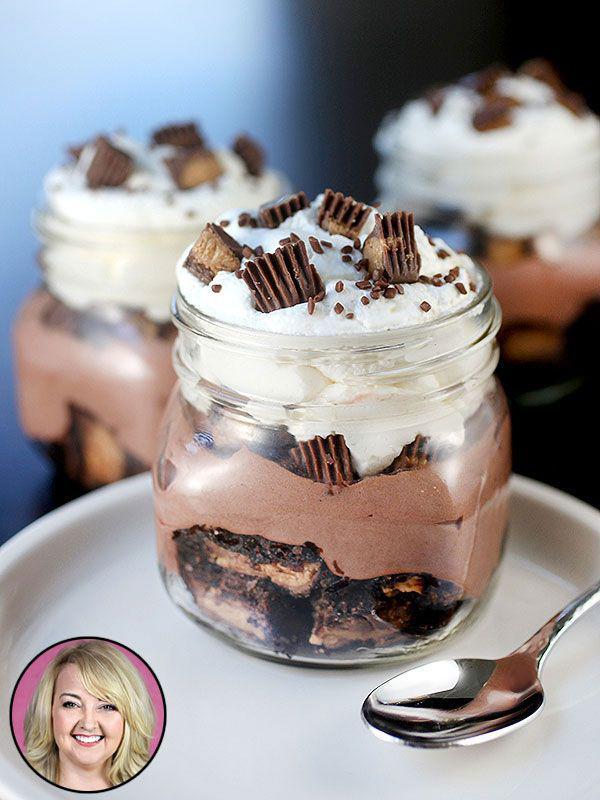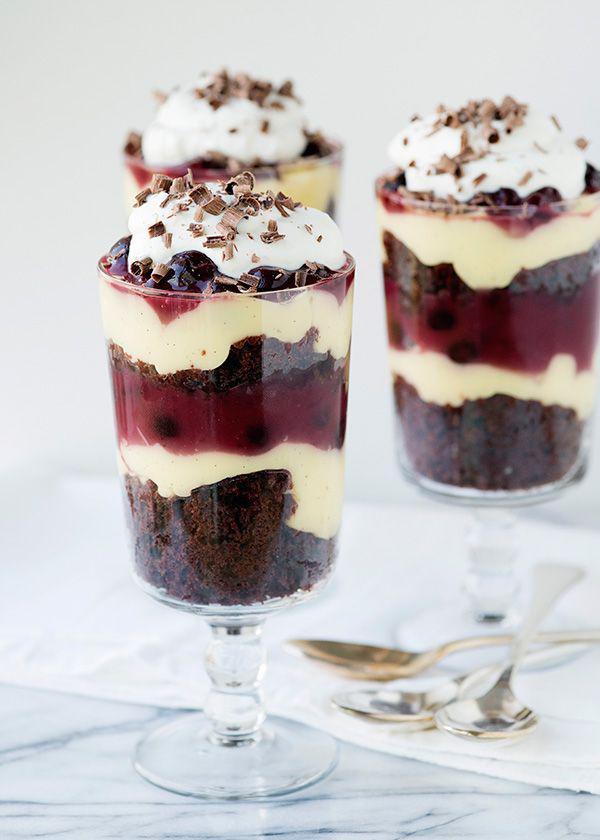The first image is the image on the left, the second image is the image on the right. Analyze the images presented: Is the assertion "There is one layered dessert in each image, and they are both in dishes with stems." valid? Answer yes or no. No. 